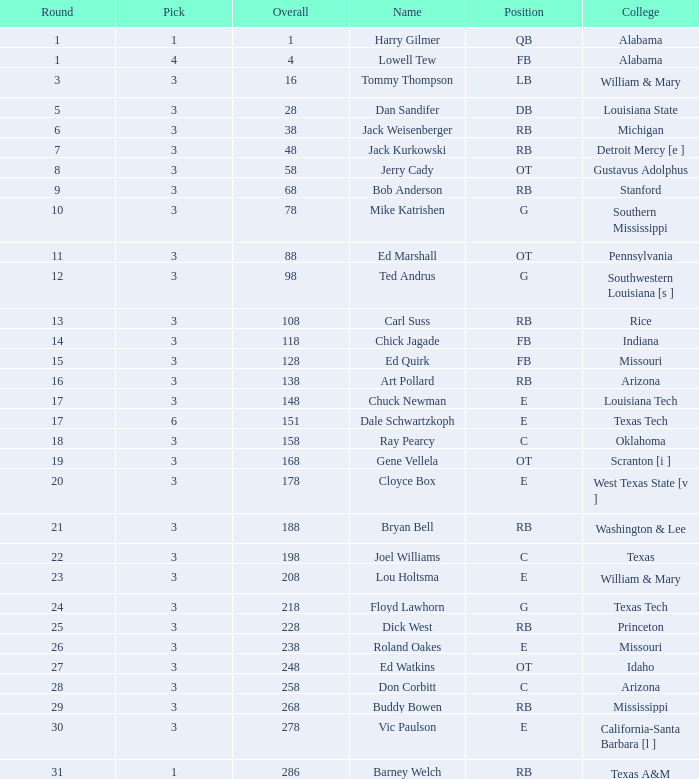How much Overall has a Name of bob anderson? 1.0. 